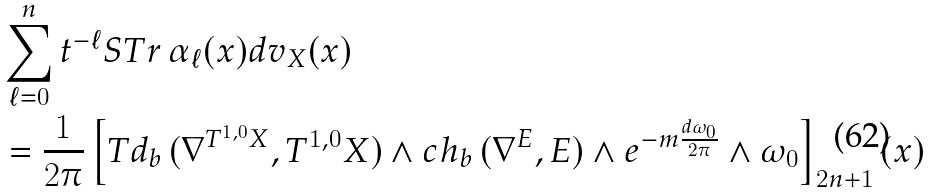<formula> <loc_0><loc_0><loc_500><loc_500>& \sum ^ { n } _ { \ell = 0 } t ^ { - \ell } S T r \, \alpha _ { \ell } ( x ) d v _ { X } ( x ) \\ & = \frac { 1 } { 2 \pi } \left [ T d _ { b } \, ( \nabla ^ { T ^ { 1 , 0 } X } , T ^ { 1 , 0 } X ) \wedge c h _ { b } \, ( \nabla ^ { E } , E ) \wedge e ^ { - m \frac { d \omega _ { 0 } } { 2 \pi } } \wedge \omega _ { 0 } \right ] _ { 2 n + 1 } ( x )</formula> 